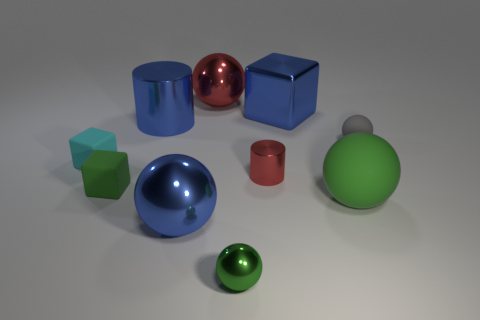What color is the small matte thing that is the same shape as the green metal thing?
Provide a short and direct response. Gray. Are there the same number of small green metal balls that are in front of the tiny shiny sphere and objects?
Your response must be concise. No. How many spheres are both to the right of the big metallic block and behind the tiny cyan block?
Offer a very short reply. 1. There is a blue thing that is the same shape as the cyan object; what size is it?
Your answer should be very brief. Large. How many small green balls have the same material as the cyan object?
Ensure brevity in your answer.  0. Are there fewer metallic balls left of the large blue cylinder than big blue metal objects?
Your answer should be compact. Yes. What number of objects are there?
Your answer should be compact. 10. What number of big things are the same color as the small shiny sphere?
Ensure brevity in your answer.  1. Is the shape of the big red metal object the same as the tiny cyan rubber thing?
Your answer should be compact. No. What size is the cube behind the rubber cube behind the small green rubber cube?
Offer a terse response. Large. 